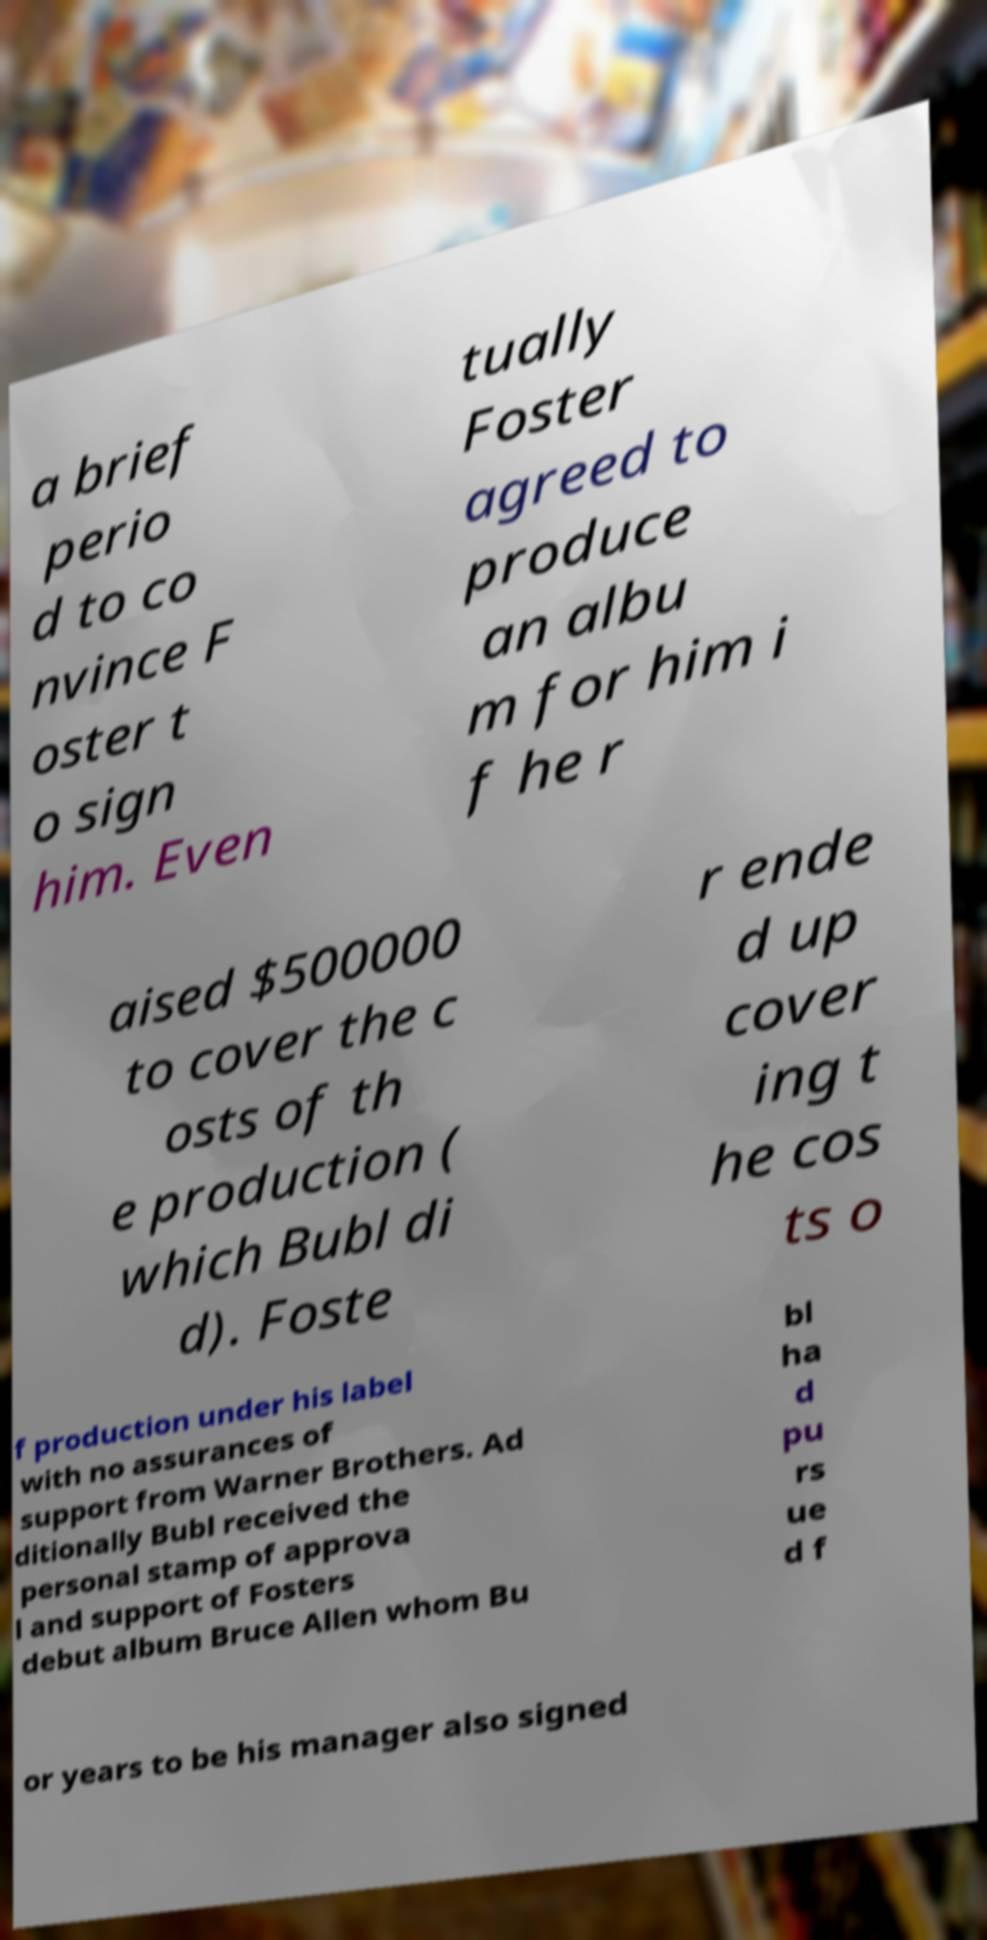What messages or text are displayed in this image? I need them in a readable, typed format. a brief perio d to co nvince F oster t o sign him. Even tually Foster agreed to produce an albu m for him i f he r aised $500000 to cover the c osts of th e production ( which Bubl di d). Foste r ende d up cover ing t he cos ts o f production under his label with no assurances of support from Warner Brothers. Ad ditionally Bubl received the personal stamp of approva l and support of Fosters debut album Bruce Allen whom Bu bl ha d pu rs ue d f or years to be his manager also signed 